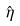Convert formula to latex. <formula><loc_0><loc_0><loc_500><loc_500>\hat { \eta }</formula> 